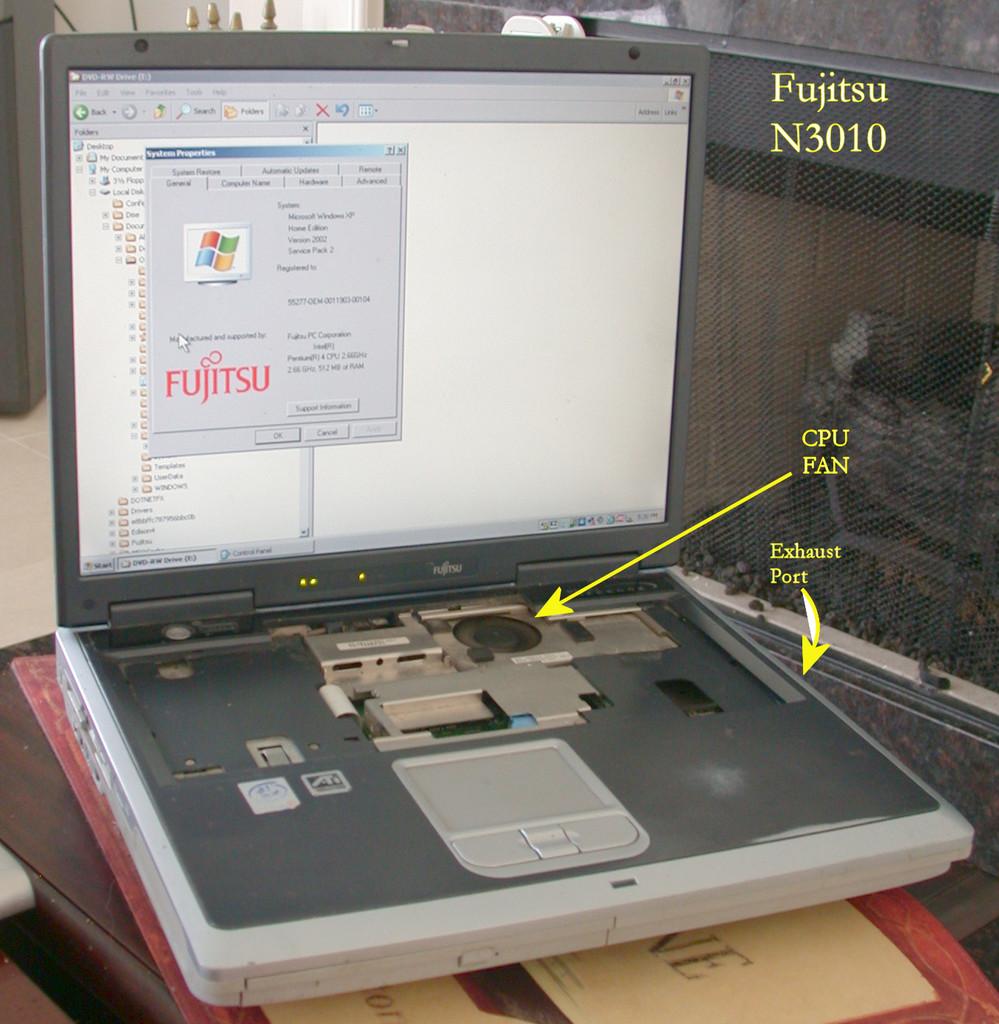Is the cpu fan labeled?
Your answer should be compact. Yes. Is that a windows laptop?
Your response must be concise. Yes. 